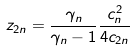Convert formula to latex. <formula><loc_0><loc_0><loc_500><loc_500>z _ { 2 n } = \frac { \gamma _ { n } } { \gamma _ { n } - 1 } \frac { c _ { n } ^ { 2 } } { 4 c _ { 2 n } }</formula> 